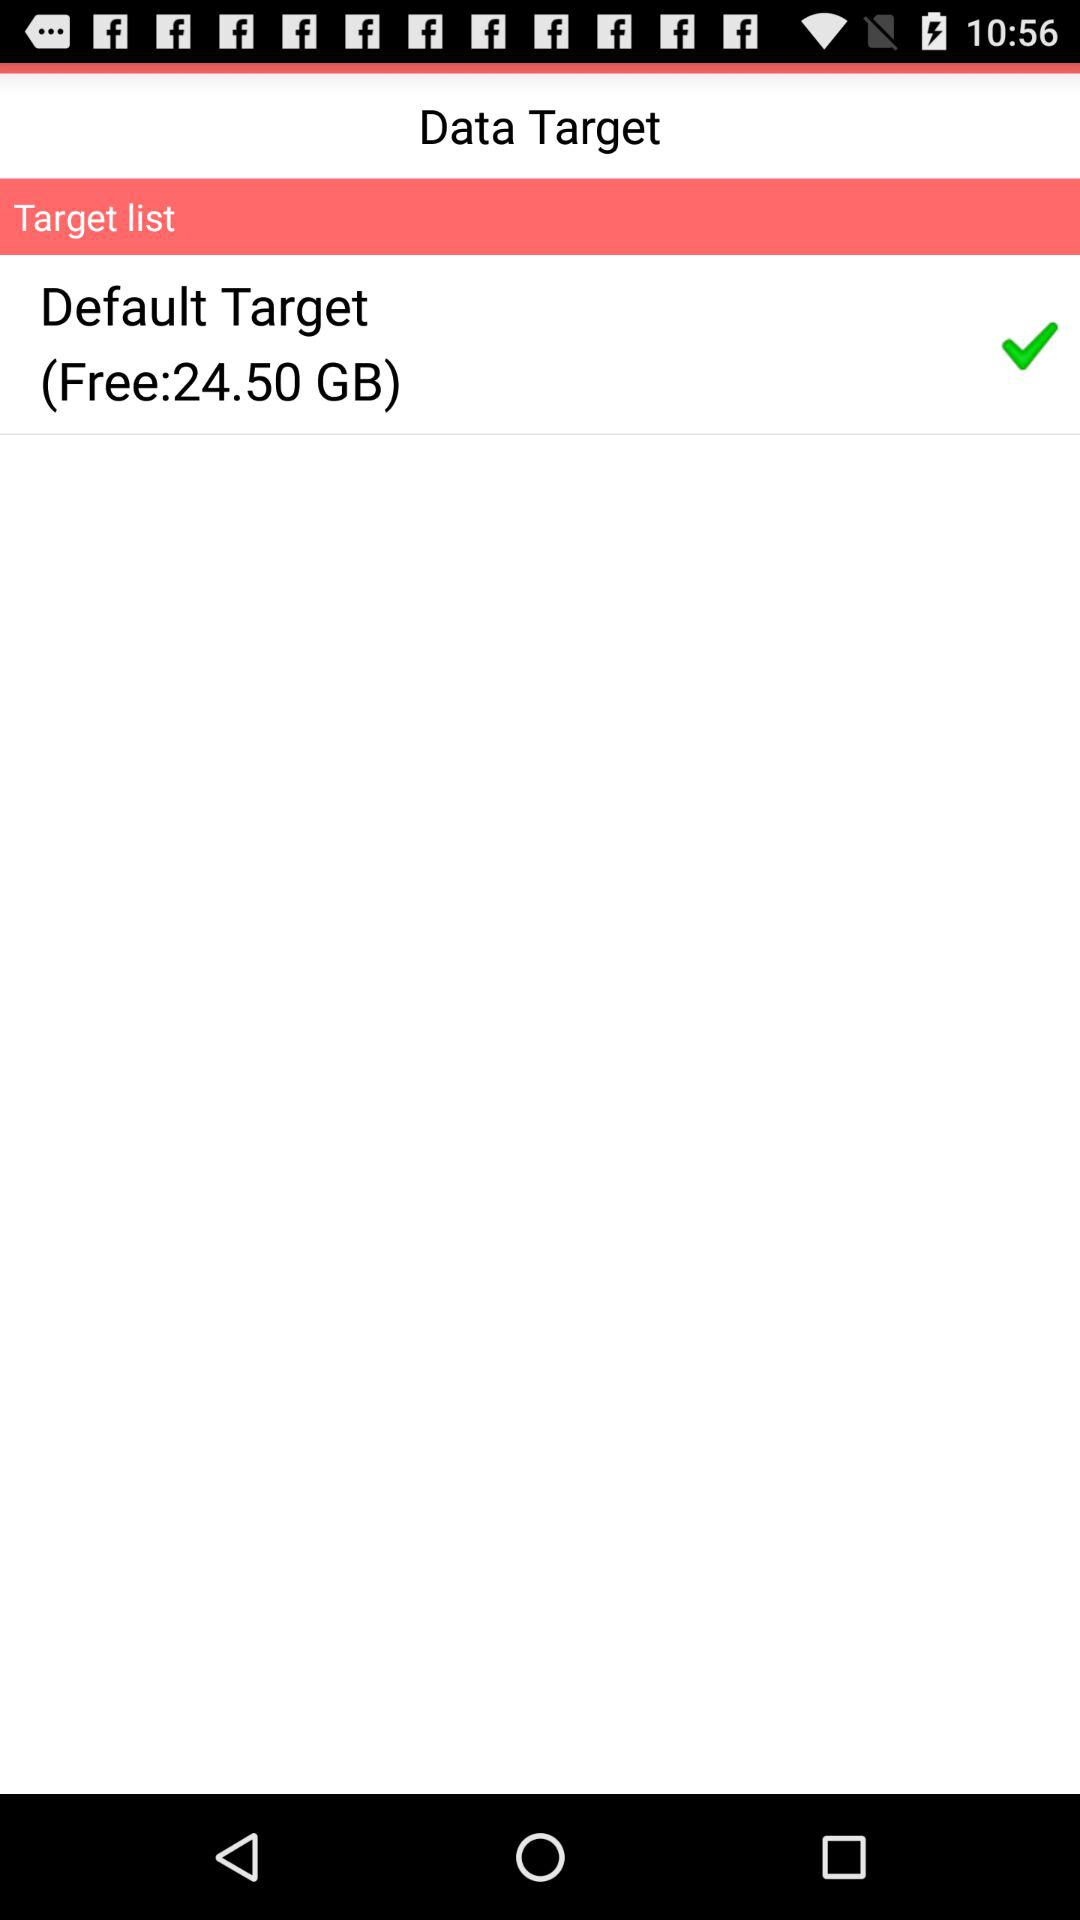How much free space is available? The available free space is 24.50 GB. 